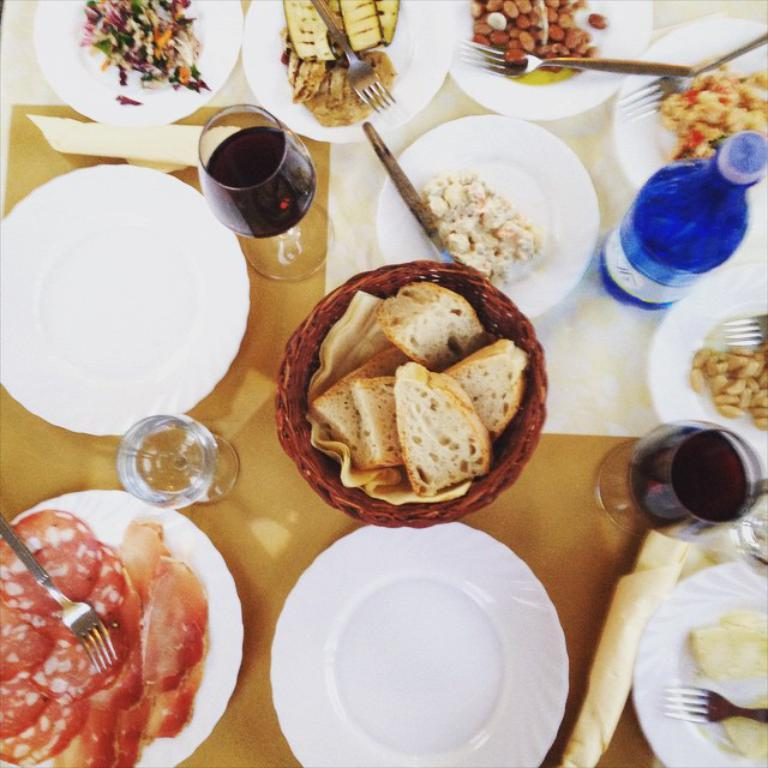What piece of furniture is present in the image? There is a table in the image. What items are placed on the table? There are plates, bottles, glasses, spoons, forks, and food on the table. What type of utensils can be seen on the table? Spoons and forks are on the table. What is the purpose of the bottles and glasses on the table? The bottles and glasses are likely for holding drinks. Where is the grandmother sitting in the image? There is no grandmother present in the image. What type of worm can be seen crawling on the food in the image? There are no worms present in the image; the food appears to be clean and untouched. 